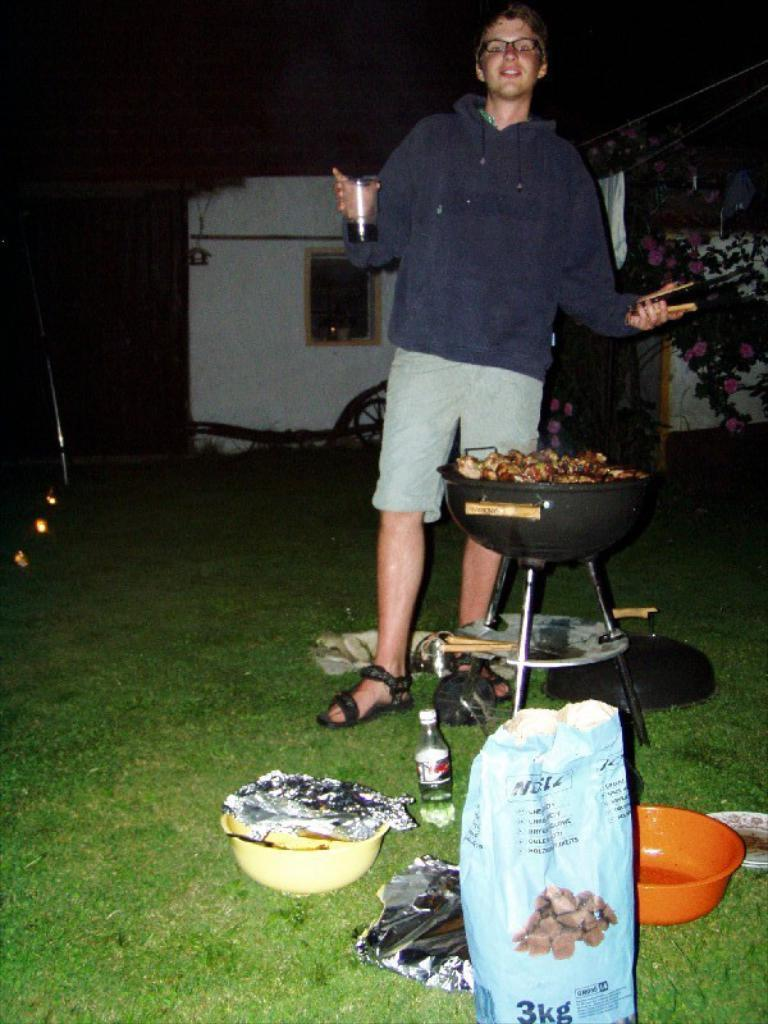<image>
Summarize the visual content of the image. A man at a grill with a blue bag infront that says 3kg. 